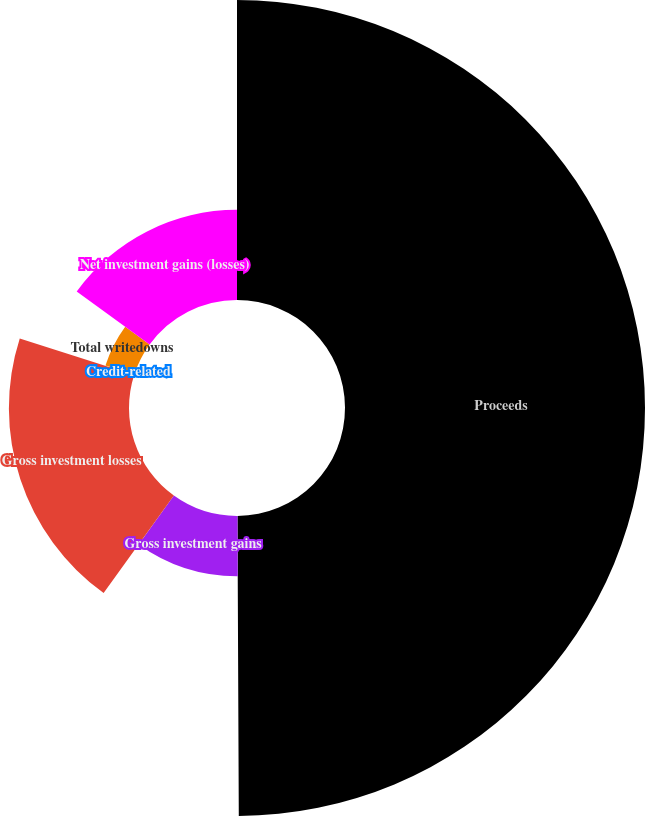Convert chart. <chart><loc_0><loc_0><loc_500><loc_500><pie_chart><fcel>Proceeds<fcel>Gross investment gains<fcel>Gross investment losses<fcel>Credit-related<fcel>Total writedowns<fcel>Net investment gains (losses)<nl><fcel>49.93%<fcel>10.01%<fcel>19.99%<fcel>0.04%<fcel>5.03%<fcel>15.0%<nl></chart> 